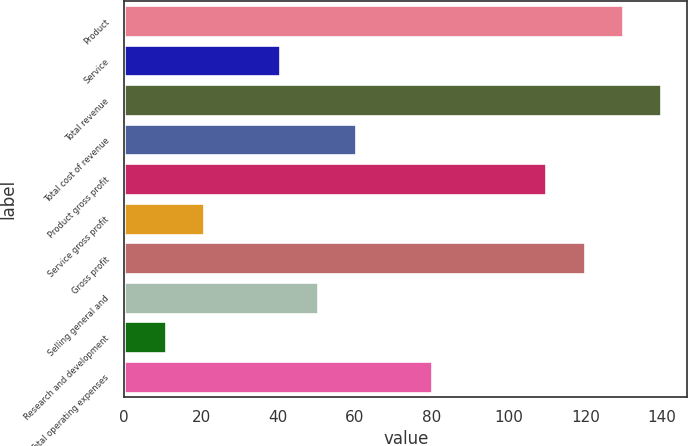Convert chart. <chart><loc_0><loc_0><loc_500><loc_500><bar_chart><fcel>Product<fcel>Service<fcel>Total revenue<fcel>Total cost of revenue<fcel>Product gross profit<fcel>Service gross profit<fcel>Gross profit<fcel>Selling general and<fcel>Research and development<fcel>Total operating expenses<nl><fcel>129.7<fcel>40.6<fcel>139.6<fcel>60.4<fcel>109.9<fcel>20.8<fcel>119.8<fcel>50.5<fcel>10.9<fcel>80.2<nl></chart> 